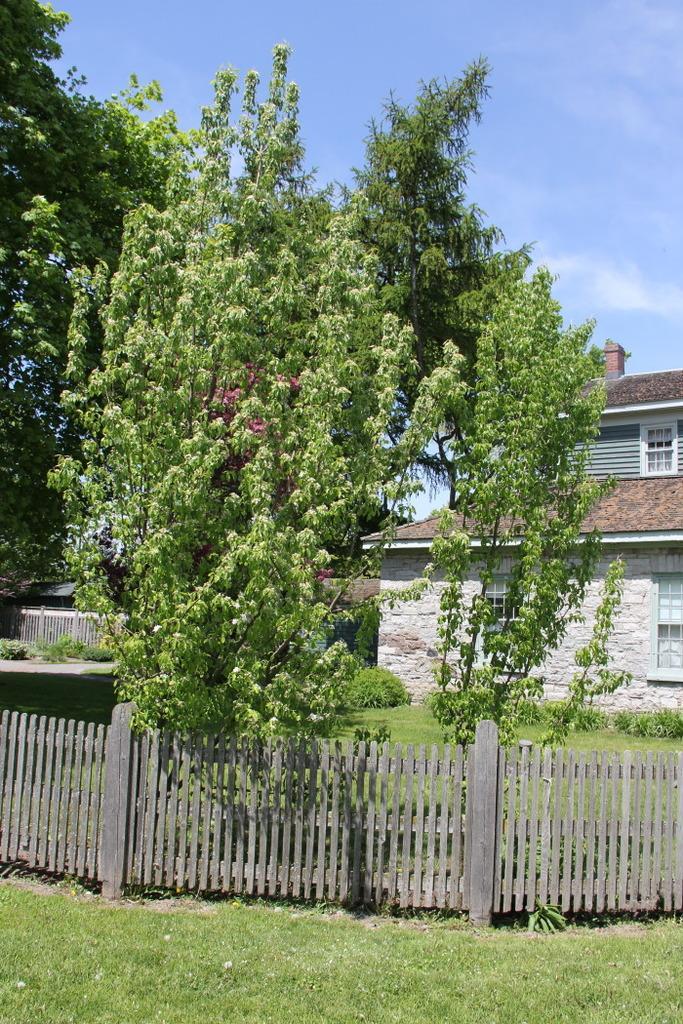Please provide a concise description of this image. This picture is clicked outside. In the foreground we can see the green grass and a wooden fence. In the center we can see the trees, plants and the building and we can see the chimney, windows of the building. In the background there is a sky. 